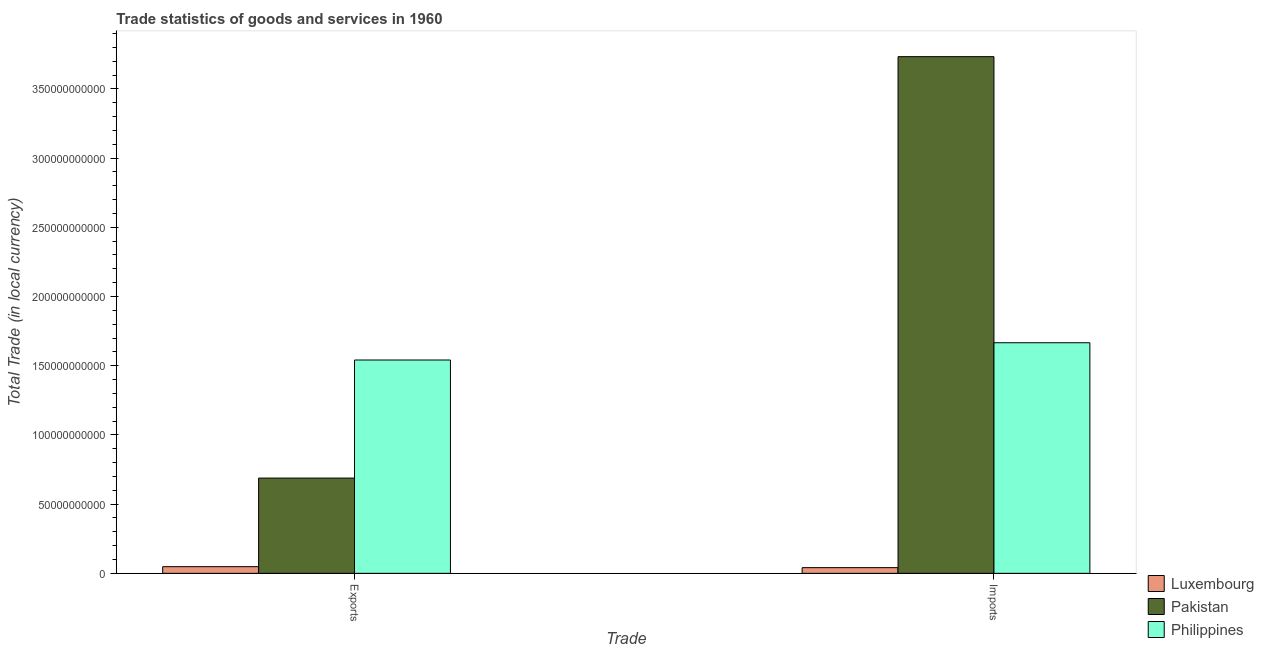How many groups of bars are there?
Offer a terse response. 2. Are the number of bars per tick equal to the number of legend labels?
Keep it short and to the point. Yes. Are the number of bars on each tick of the X-axis equal?
Your answer should be compact. Yes. How many bars are there on the 1st tick from the right?
Give a very brief answer. 3. What is the label of the 1st group of bars from the left?
Provide a succinct answer. Exports. What is the imports of goods and services in Philippines?
Provide a succinct answer. 1.67e+11. Across all countries, what is the maximum export of goods and services?
Provide a short and direct response. 1.54e+11. Across all countries, what is the minimum imports of goods and services?
Make the answer very short. 4.11e+09. In which country was the imports of goods and services maximum?
Your answer should be compact. Pakistan. In which country was the imports of goods and services minimum?
Give a very brief answer. Luxembourg. What is the total imports of goods and services in the graph?
Your answer should be compact. 5.44e+11. What is the difference between the imports of goods and services in Luxembourg and that in Philippines?
Provide a succinct answer. -1.62e+11. What is the difference between the export of goods and services in Luxembourg and the imports of goods and services in Philippines?
Your answer should be compact. -1.62e+11. What is the average export of goods and services per country?
Give a very brief answer. 7.59e+1. What is the difference between the export of goods and services and imports of goods and services in Pakistan?
Provide a short and direct response. -3.04e+11. In how many countries, is the imports of goods and services greater than 40000000000 LCU?
Keep it short and to the point. 2. What is the ratio of the export of goods and services in Philippines to that in Pakistan?
Your answer should be very brief. 2.24. Is the imports of goods and services in Luxembourg less than that in Philippines?
Offer a terse response. Yes. In how many countries, is the export of goods and services greater than the average export of goods and services taken over all countries?
Provide a succinct answer. 1. What does the 2nd bar from the left in Exports represents?
Make the answer very short. Pakistan. Does the graph contain any zero values?
Keep it short and to the point. No. Does the graph contain grids?
Give a very brief answer. No. Where does the legend appear in the graph?
Your response must be concise. Bottom right. How many legend labels are there?
Make the answer very short. 3. What is the title of the graph?
Make the answer very short. Trade statistics of goods and services in 1960. What is the label or title of the X-axis?
Offer a very short reply. Trade. What is the label or title of the Y-axis?
Provide a succinct answer. Total Trade (in local currency). What is the Total Trade (in local currency) of Luxembourg in Exports?
Give a very brief answer. 4.81e+09. What is the Total Trade (in local currency) of Pakistan in Exports?
Your answer should be compact. 6.88e+1. What is the Total Trade (in local currency) of Philippines in Exports?
Provide a short and direct response. 1.54e+11. What is the Total Trade (in local currency) in Luxembourg in Imports?
Offer a terse response. 4.11e+09. What is the Total Trade (in local currency) in Pakistan in Imports?
Keep it short and to the point. 3.73e+11. What is the Total Trade (in local currency) of Philippines in Imports?
Provide a short and direct response. 1.67e+11. Across all Trade, what is the maximum Total Trade (in local currency) in Luxembourg?
Ensure brevity in your answer.  4.81e+09. Across all Trade, what is the maximum Total Trade (in local currency) in Pakistan?
Provide a short and direct response. 3.73e+11. Across all Trade, what is the maximum Total Trade (in local currency) of Philippines?
Provide a short and direct response. 1.67e+11. Across all Trade, what is the minimum Total Trade (in local currency) of Luxembourg?
Offer a very short reply. 4.11e+09. Across all Trade, what is the minimum Total Trade (in local currency) of Pakistan?
Your answer should be compact. 6.88e+1. Across all Trade, what is the minimum Total Trade (in local currency) in Philippines?
Your answer should be very brief. 1.54e+11. What is the total Total Trade (in local currency) of Luxembourg in the graph?
Provide a succinct answer. 8.92e+09. What is the total Total Trade (in local currency) of Pakistan in the graph?
Your response must be concise. 4.42e+11. What is the total Total Trade (in local currency) in Philippines in the graph?
Offer a very short reply. 3.21e+11. What is the difference between the Total Trade (in local currency) in Luxembourg in Exports and that in Imports?
Give a very brief answer. 7.00e+08. What is the difference between the Total Trade (in local currency) of Pakistan in Exports and that in Imports?
Offer a terse response. -3.04e+11. What is the difference between the Total Trade (in local currency) of Philippines in Exports and that in Imports?
Give a very brief answer. -1.25e+1. What is the difference between the Total Trade (in local currency) of Luxembourg in Exports and the Total Trade (in local currency) of Pakistan in Imports?
Keep it short and to the point. -3.68e+11. What is the difference between the Total Trade (in local currency) in Luxembourg in Exports and the Total Trade (in local currency) in Philippines in Imports?
Your answer should be compact. -1.62e+11. What is the difference between the Total Trade (in local currency) of Pakistan in Exports and the Total Trade (in local currency) of Philippines in Imports?
Provide a succinct answer. -9.78e+1. What is the average Total Trade (in local currency) of Luxembourg per Trade?
Your answer should be compact. 4.46e+09. What is the average Total Trade (in local currency) in Pakistan per Trade?
Offer a terse response. 2.21e+11. What is the average Total Trade (in local currency) in Philippines per Trade?
Your answer should be very brief. 1.60e+11. What is the difference between the Total Trade (in local currency) in Luxembourg and Total Trade (in local currency) in Pakistan in Exports?
Make the answer very short. -6.40e+1. What is the difference between the Total Trade (in local currency) of Luxembourg and Total Trade (in local currency) of Philippines in Exports?
Your answer should be compact. -1.49e+11. What is the difference between the Total Trade (in local currency) in Pakistan and Total Trade (in local currency) in Philippines in Exports?
Provide a succinct answer. -8.53e+1. What is the difference between the Total Trade (in local currency) of Luxembourg and Total Trade (in local currency) of Pakistan in Imports?
Provide a short and direct response. -3.69e+11. What is the difference between the Total Trade (in local currency) of Luxembourg and Total Trade (in local currency) of Philippines in Imports?
Offer a very short reply. -1.62e+11. What is the difference between the Total Trade (in local currency) in Pakistan and Total Trade (in local currency) in Philippines in Imports?
Give a very brief answer. 2.07e+11. What is the ratio of the Total Trade (in local currency) of Luxembourg in Exports to that in Imports?
Ensure brevity in your answer.  1.17. What is the ratio of the Total Trade (in local currency) of Pakistan in Exports to that in Imports?
Your response must be concise. 0.18. What is the ratio of the Total Trade (in local currency) in Philippines in Exports to that in Imports?
Keep it short and to the point. 0.93. What is the difference between the highest and the second highest Total Trade (in local currency) in Luxembourg?
Offer a terse response. 7.00e+08. What is the difference between the highest and the second highest Total Trade (in local currency) of Pakistan?
Keep it short and to the point. 3.04e+11. What is the difference between the highest and the second highest Total Trade (in local currency) of Philippines?
Your response must be concise. 1.25e+1. What is the difference between the highest and the lowest Total Trade (in local currency) in Luxembourg?
Your answer should be compact. 7.00e+08. What is the difference between the highest and the lowest Total Trade (in local currency) in Pakistan?
Provide a succinct answer. 3.04e+11. What is the difference between the highest and the lowest Total Trade (in local currency) of Philippines?
Your answer should be very brief. 1.25e+1. 